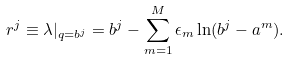<formula> <loc_0><loc_0><loc_500><loc_500>r ^ { j } \equiv \lambda | _ { q = b ^ { j } } = b ^ { j } - \sum _ { m = 1 } ^ { M } \epsilon _ { m } \ln ( b ^ { j } - a ^ { m } ) .</formula> 